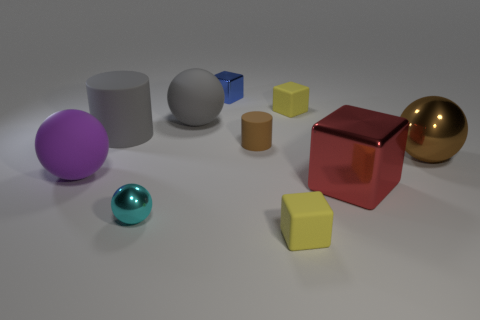What number of red objects are either large things or small metallic blocks?
Make the answer very short. 1. Are there any large matte objects that are in front of the small brown object that is left of the yellow matte object that is in front of the big purple ball?
Offer a very short reply. Yes. Are there fewer brown metallic spheres than big spheres?
Provide a short and direct response. Yes. There is a small matte thing that is in front of the brown sphere; does it have the same shape as the brown metal thing?
Make the answer very short. No. Is there a brown metal object?
Keep it short and to the point. Yes. What is the color of the metallic ball that is to the left of the small rubber object right of the yellow cube in front of the large shiny block?
Give a very brief answer. Cyan. Is the number of tiny brown matte cylinders that are behind the brown matte object the same as the number of yellow cubes that are in front of the big brown metallic object?
Your answer should be very brief. No. What is the shape of the gray rubber object that is the same size as the gray matte ball?
Your answer should be compact. Cylinder. Is there a object that has the same color as the big cylinder?
Offer a very short reply. Yes. What shape is the tiny metallic object right of the small ball?
Ensure brevity in your answer.  Cube. 